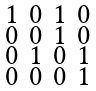<formula> <loc_0><loc_0><loc_500><loc_500>\begin{smallmatrix} 1 & 0 & 1 & 0 \\ 0 & 0 & 1 & 0 \\ 0 & 1 & 0 & 1 \\ 0 & 0 & 0 & 1 \end{smallmatrix}</formula> 